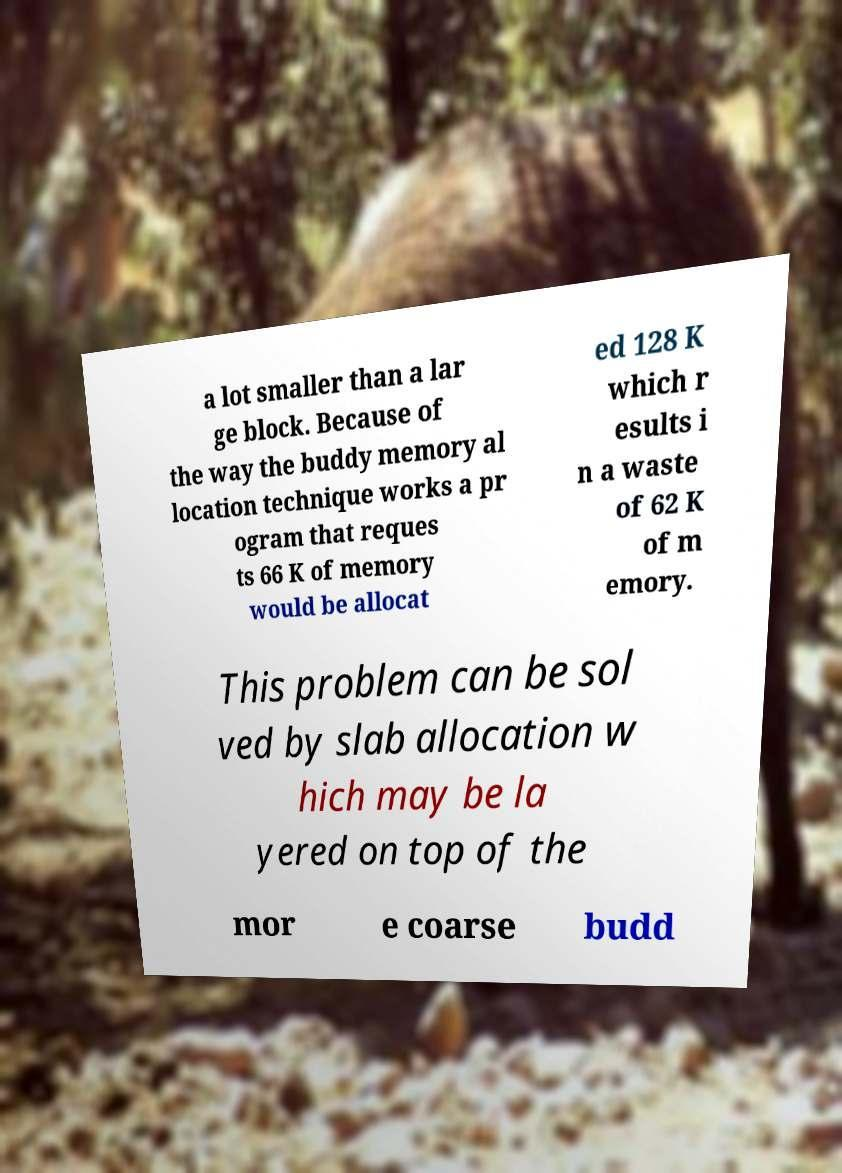Can you read and provide the text displayed in the image?This photo seems to have some interesting text. Can you extract and type it out for me? a lot smaller than a lar ge block. Because of the way the buddy memory al location technique works a pr ogram that reques ts 66 K of memory would be allocat ed 128 K which r esults i n a waste of 62 K of m emory. This problem can be sol ved by slab allocation w hich may be la yered on top of the mor e coarse budd 